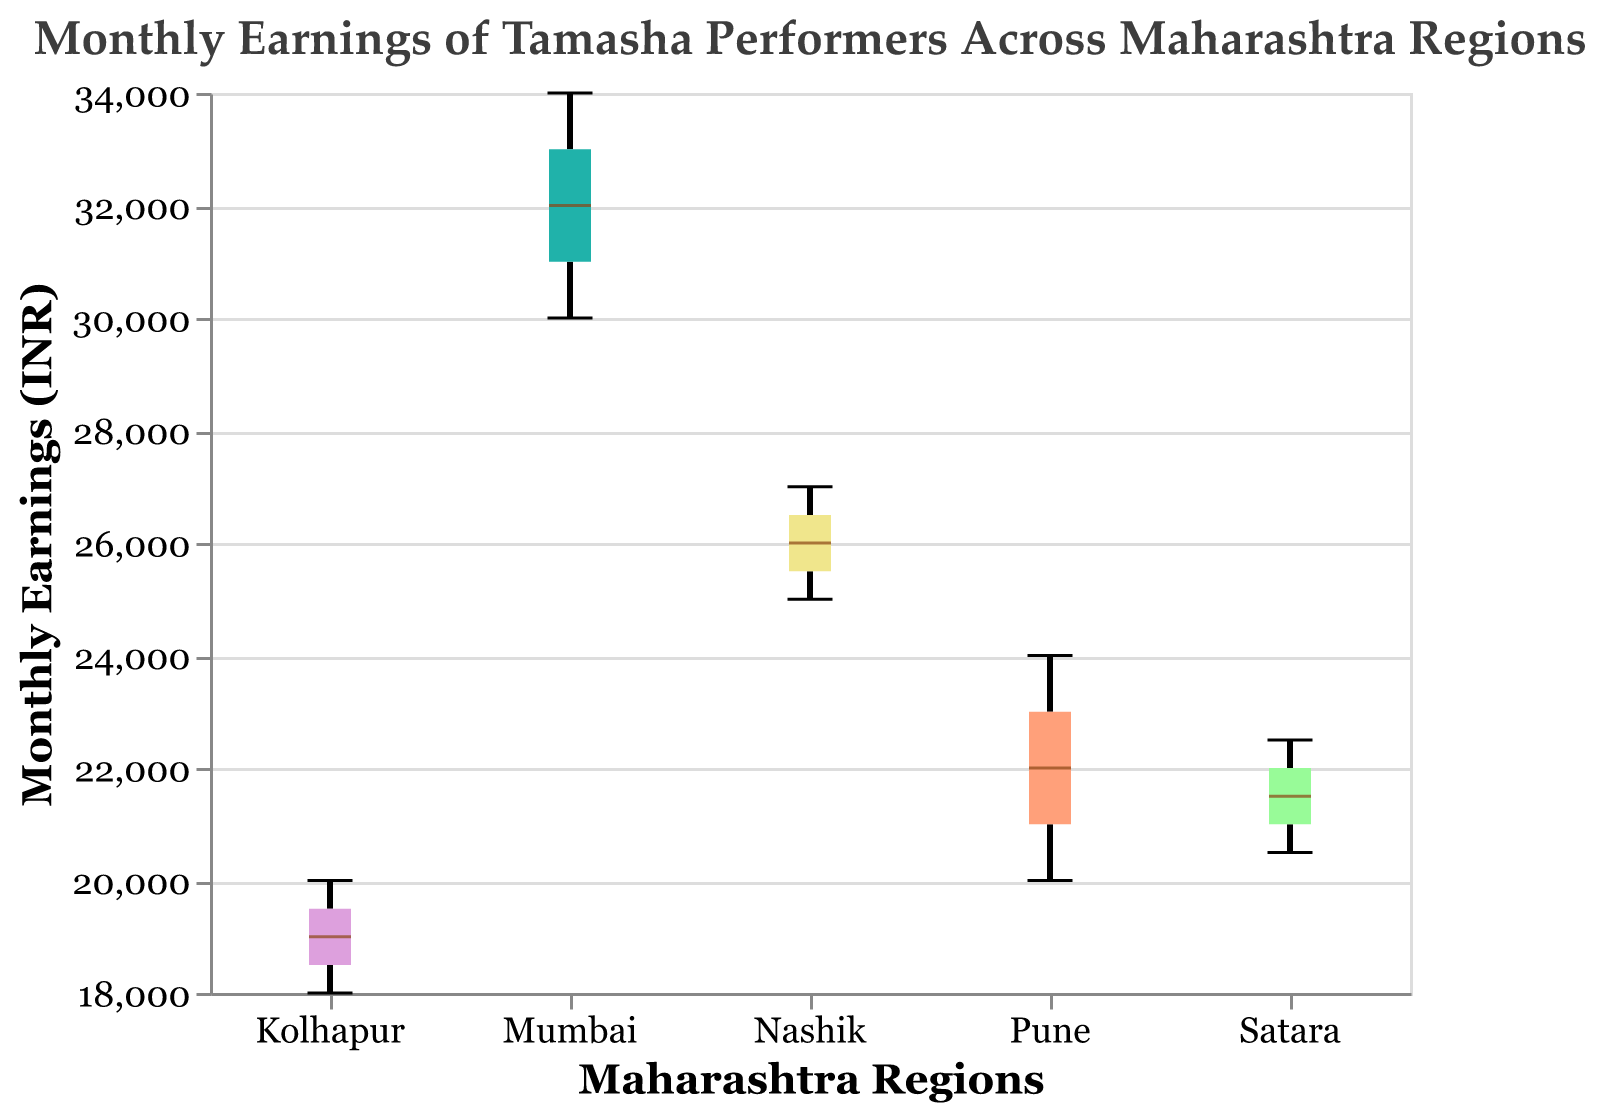What is the title of the figure? The title of the figure is visible at the top of the plot. It is mentioned that way in the plotting code provided.
Answer: Monthly Earnings of Tamasha Performers Across Maharashtra Regions What regions are represented in the plot? The x-axis of the plot displays the regions represented, which are mentioned in the "Region" field of the data.
Answer: Pune, Mumbai, Kolhapur, Nashik, Satara Which region has the highest median monthly earnings? The median of each region is indicated by a horizontal line within each box on the boxplot.
Answer: Mumbai Which region has the lowest range of monthly earnings? The range of monthly earnings for each region is represented by the length of the boxes in the boxplot. The region with the shortest box has the lowest range.
Answer: Satara What is the median monthly earning for performers in Pune? The median is represented by a horizontal line within the Pune box.
Answer: 22000 How does the median of Mumbai compare to the median of Kolhapur? The median of Mumbai is represented by a horizontal line in the Mumbai box, while the median of Kolhapur is represented similarly in the Kolhapur box. By visually comparing them, it is clear which is higher.
Answer: The median of Mumbai is higher What are the monthly earnings of the performer with the highest monthly earnings in Nashik? The highest monthly earnings in Nashik are indicated at the top end of the Nashik box, representing the maximum value within the Nashik boxplot whiskers.
Answer: 27000 What is the interquartile range (IQR) of monthly earnings for performers in Kolhapur? The IQR is the range between the lower quartile and upper quartile values within the Kolhapur box. It can be calculated by subtracting the lower quartile value from the upper quartile value.
Answer: 2000 (from 18000 to 20000) Which region shows the most variability in monthly earnings? Variability is measured by the length of the boxes and whiskers in the boxplot. The region with the longest box and whiskers shows the most variability.
Answer: Mumbai Are there any outliers in the data for any region? Outliers in a boxplot are typically indicated by points that fall outside the whiskers of the boxes. Visual inspection can confirm their presence or absence.
Answer: No, there are no outliers 